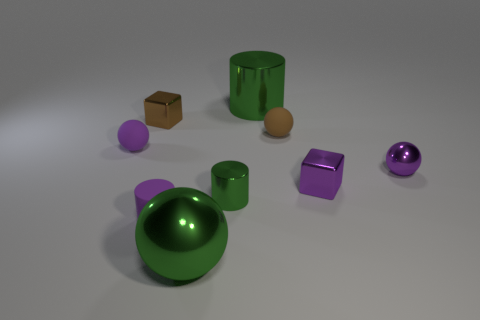What size is the shiny cylinder behind the small block in front of the purple ball right of the small purple matte cylinder?
Your response must be concise. Large. There is a brown shiny object; what shape is it?
Offer a very short reply. Cube. The shiny sphere that is the same color as the large cylinder is what size?
Offer a terse response. Large. How many large green metallic cylinders are behind the big object right of the green ball?
Your answer should be compact. 0. What number of other things are there of the same material as the purple block
Give a very brief answer. 5. Do the small brown thing on the right side of the purple matte cylinder and the tiny brown thing that is to the left of the large green sphere have the same material?
Provide a succinct answer. No. Is there anything else that is the same shape as the small green metal object?
Your answer should be very brief. Yes. Is the material of the brown block the same as the purple sphere that is left of the purple cylinder?
Ensure brevity in your answer.  No. There is a metallic cylinder in front of the small rubber thing that is to the left of the shiny cube that is behind the small purple block; what color is it?
Offer a terse response. Green. What shape is the object that is the same size as the green sphere?
Ensure brevity in your answer.  Cylinder. 